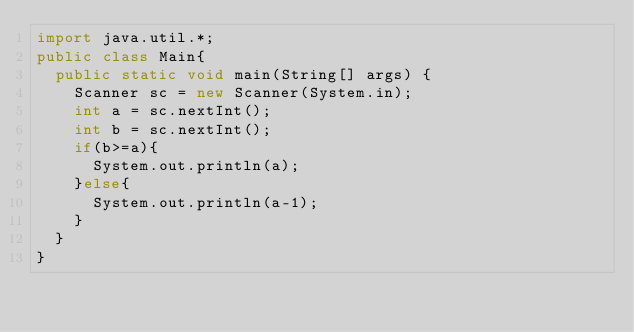Convert code to text. <code><loc_0><loc_0><loc_500><loc_500><_Java_>import java.util.*;
public class Main{
  public static void main(String[] args) {
    Scanner sc = new Scanner(System.in);
    int a = sc.nextInt();
    int b = sc.nextInt();
    if(b>=a){
      System.out.println(a);
    }else{
      System.out.println(a-1);
    }
  }
}
</code> 